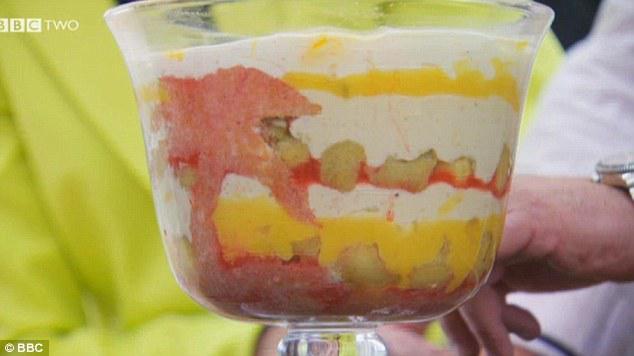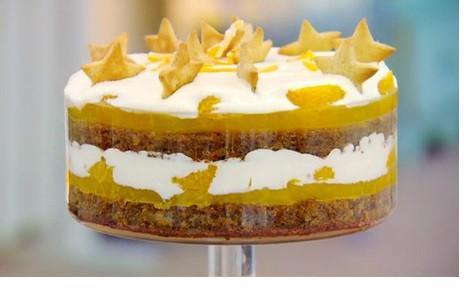The first image is the image on the left, the second image is the image on the right. Analyze the images presented: Is the assertion "the desserts have rolled up cake involved" valid? Answer yes or no. No. The first image is the image on the left, the second image is the image on the right. Given the left and right images, does the statement "All of the trifles are topped with blueberries or raspberries." hold true? Answer yes or no. No. 